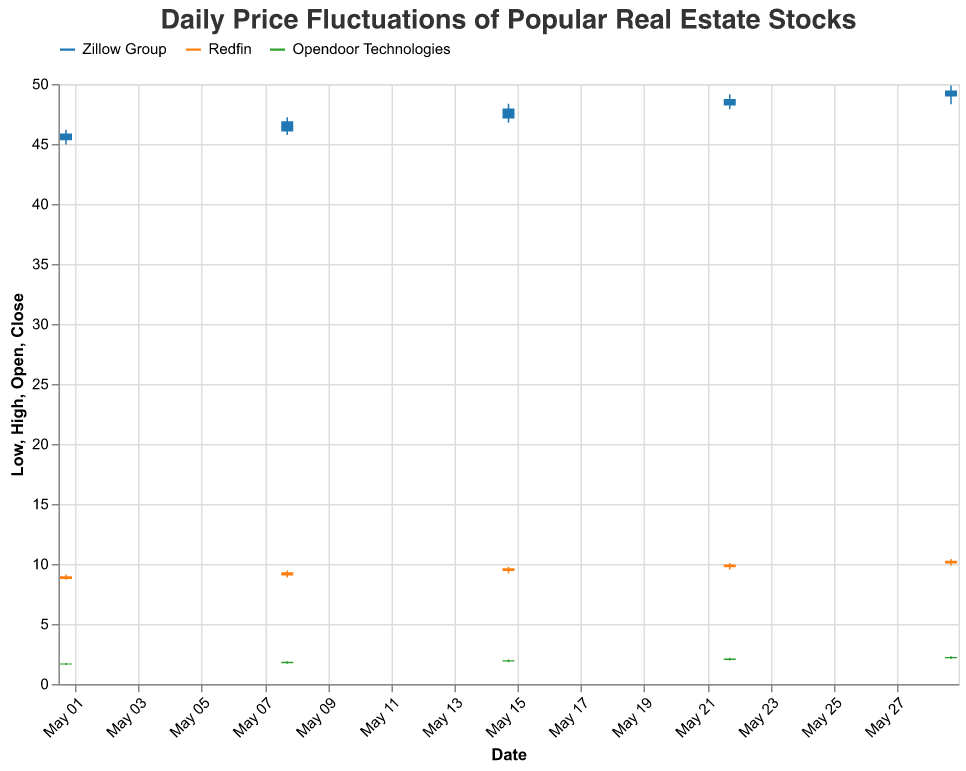What is the highest price reached by Zillow Group in May? By looking at the line labeled with Zillow Group, find the highest point on the chart.
Answer: 49.87 On what date did Redfin have the lowest closing price? Identify the points on the chart labeled with Redfin and compare the closing prices. The lowest closing price for Redfin appears on May 1 at a value of 8.98.
Answer: 2023-05-01 For Opendoor Technologies, how much did the closing price increase from May 1 to May 29? Find the closing prices for Opendoor Technologies on May 1 (1.71) and May 29 (2.25), then subtract the earlier closing price from the later one: 2.25 - 1.71.
Answer: 0.54 Which stock experienced the greatest price fluctuation (high-low) on May 15? For May 15, calculate the fluctuation for each stock by subtracting the low from the high: Zillow Group (48.36 - 46.78 = 1.58), Redfin (9.78 - 9.22 = 0.56), Opendoor Technologies (2.05 - 1.82 = 0.23). Zillow Group had the greatest fluctuation.
Answer: Zillow Group Compare the opening and closing prices of Opendoor Technologies on May 8. Did the price go up or down? Find Opendoor Technologies' opening (1.73) and closing (1.85) prices on May 8. Since 1.85 is higher, the price went up.
Answer: Up Which date shows Zillow Group having a higher closing price compared to its opening price? For each date, compare the opening and closing prices for Zillow Group. On May 1 (close: 45.87 vs open: 45.32), May 8 (close: 46.89 vs open: 46.05), May 15 (close: 47.95 vs open: 47.12), May 22 (close: 48.76 vs open: 48.21), and May 29 (close: 49.45 vs open: 48.95), all dates show higher closing prices compared to the opening.
Answer: All dates By what amount did Redfin's closing price increase from May 8 to May 15? Check the closing prices for Redfin on May 8 (9.32) and May 15 (9.65), then subtract: 9.65 - 9.32.
Answer: 0.33 Which stock had the lowest high price on May 22? Compare the high prices on May 22 for each stock: Zillow Group (49.15), Redfin (10.08), Opendoor Technologies (2.18). Opendoor Technologies has the lowest high price.
Answer: Opendoor Technologies What was the opening price for Redfin on the last date in May shown in the chart? Find the opening price for Redfin on May 29, which is 10.05.
Answer: 10.05 